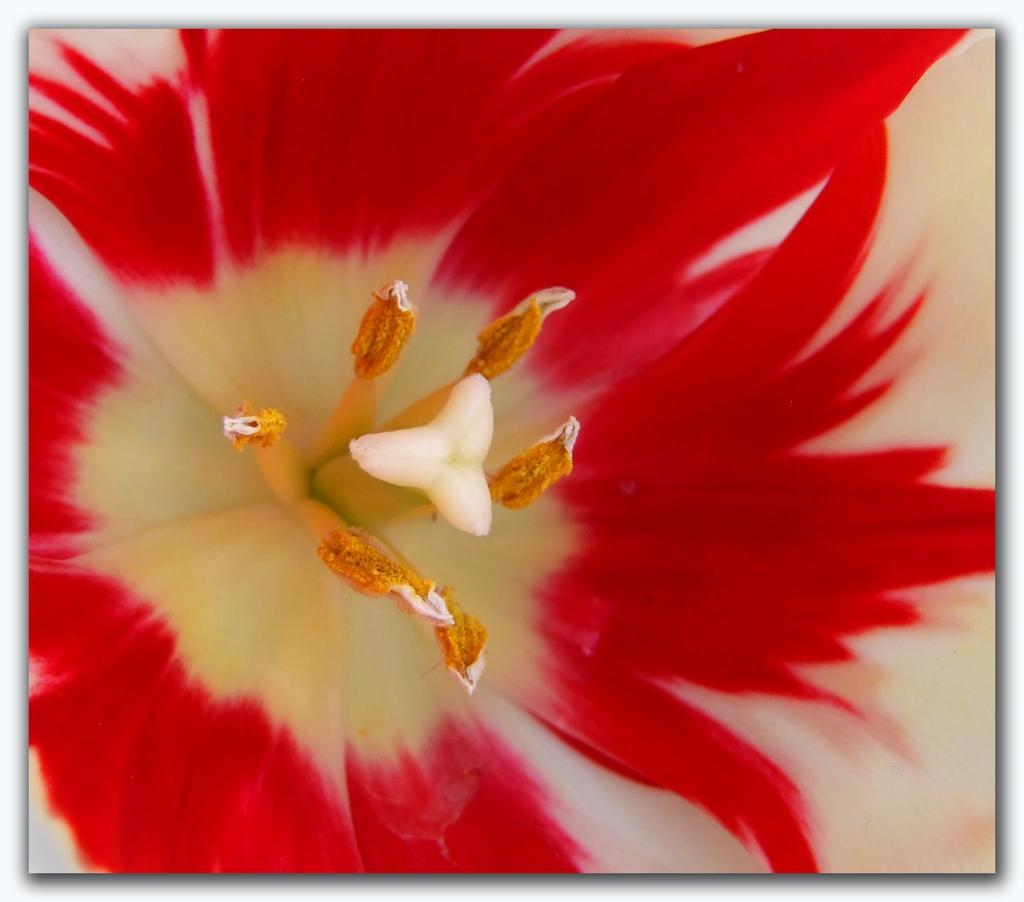Please provide a concise description of this image. In this image we can see a flower. 